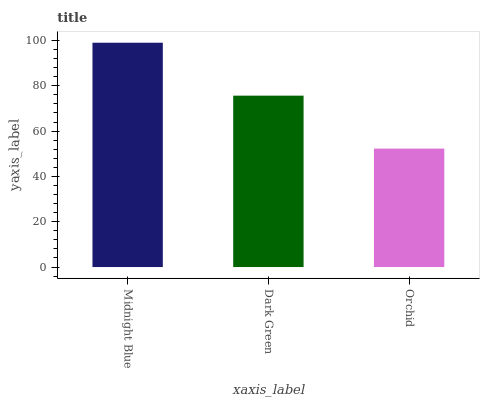Is Orchid the minimum?
Answer yes or no. Yes. Is Midnight Blue the maximum?
Answer yes or no. Yes. Is Dark Green the minimum?
Answer yes or no. No. Is Dark Green the maximum?
Answer yes or no. No. Is Midnight Blue greater than Dark Green?
Answer yes or no. Yes. Is Dark Green less than Midnight Blue?
Answer yes or no. Yes. Is Dark Green greater than Midnight Blue?
Answer yes or no. No. Is Midnight Blue less than Dark Green?
Answer yes or no. No. Is Dark Green the high median?
Answer yes or no. Yes. Is Dark Green the low median?
Answer yes or no. Yes. Is Midnight Blue the high median?
Answer yes or no. No. Is Orchid the low median?
Answer yes or no. No. 